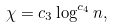<formula> <loc_0><loc_0><loc_500><loc_500>\chi = c _ { 3 } \log ^ { c _ { 4 } } n ,</formula> 